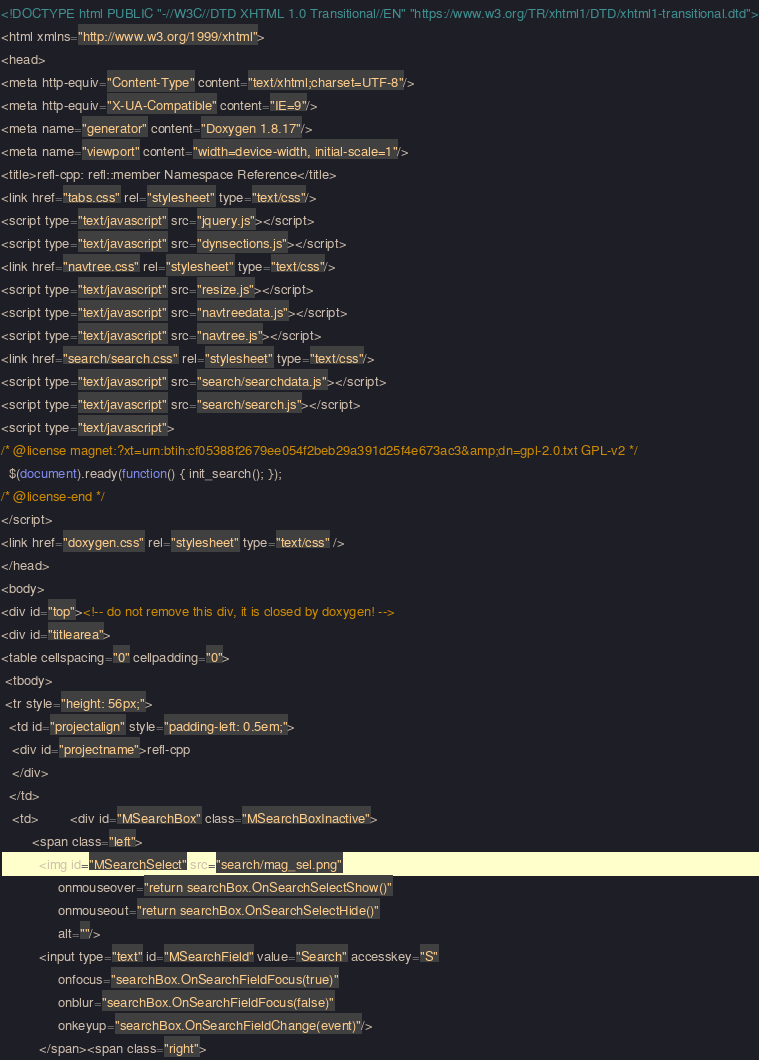Convert code to text. <code><loc_0><loc_0><loc_500><loc_500><_HTML_><!DOCTYPE html PUBLIC "-//W3C//DTD XHTML 1.0 Transitional//EN" "https://www.w3.org/TR/xhtml1/DTD/xhtml1-transitional.dtd">
<html xmlns="http://www.w3.org/1999/xhtml">
<head>
<meta http-equiv="Content-Type" content="text/xhtml;charset=UTF-8"/>
<meta http-equiv="X-UA-Compatible" content="IE=9"/>
<meta name="generator" content="Doxygen 1.8.17"/>
<meta name="viewport" content="width=device-width, initial-scale=1"/>
<title>refl-cpp: refl::member Namespace Reference</title>
<link href="tabs.css" rel="stylesheet" type="text/css"/>
<script type="text/javascript" src="jquery.js"></script>
<script type="text/javascript" src="dynsections.js"></script>
<link href="navtree.css" rel="stylesheet" type="text/css"/>
<script type="text/javascript" src="resize.js"></script>
<script type="text/javascript" src="navtreedata.js"></script>
<script type="text/javascript" src="navtree.js"></script>
<link href="search/search.css" rel="stylesheet" type="text/css"/>
<script type="text/javascript" src="search/searchdata.js"></script>
<script type="text/javascript" src="search/search.js"></script>
<script type="text/javascript">
/* @license magnet:?xt=urn:btih:cf05388f2679ee054f2beb29a391d25f4e673ac3&amp;dn=gpl-2.0.txt GPL-v2 */
  $(document).ready(function() { init_search(); });
/* @license-end */
</script>
<link href="doxygen.css" rel="stylesheet" type="text/css" />
</head>
<body>
<div id="top"><!-- do not remove this div, it is closed by doxygen! -->
<div id="titlearea">
<table cellspacing="0" cellpadding="0">
 <tbody>
 <tr style="height: 56px;">
  <td id="projectalign" style="padding-left: 0.5em;">
   <div id="projectname">refl-cpp
   </div>
  </td>
   <td>        <div id="MSearchBox" class="MSearchBoxInactive">
        <span class="left">
          <img id="MSearchSelect" src="search/mag_sel.png"
               onmouseover="return searchBox.OnSearchSelectShow()"
               onmouseout="return searchBox.OnSearchSelectHide()"
               alt=""/>
          <input type="text" id="MSearchField" value="Search" accesskey="S"
               onfocus="searchBox.OnSearchFieldFocus(true)" 
               onblur="searchBox.OnSearchFieldFocus(false)" 
               onkeyup="searchBox.OnSearchFieldChange(event)"/>
          </span><span class="right"></code> 